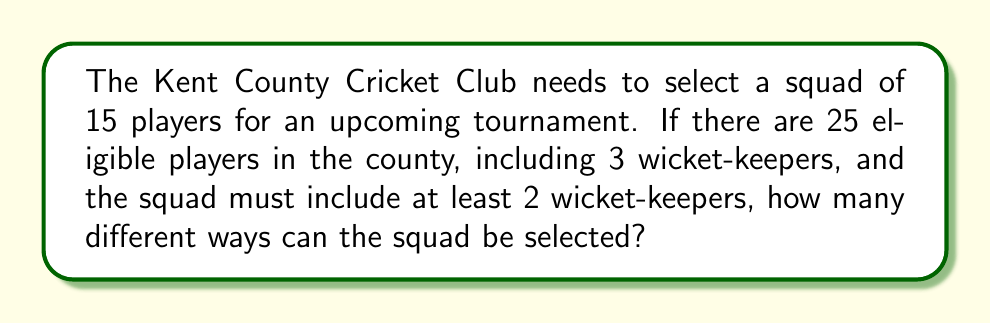What is the answer to this math problem? Let's approach this step-by-step:

1) First, we need to select the wicket-keepers:
   - We must choose at least 2 out of 3 wicket-keepers.
   - We can either choose 2 or all 3.
   - This can be done in $\binom{3}{2} + \binom{3}{3} = 3 + 1 = 4$ ways.

2) After selecting the wicket-keepers, we need to fill the remaining spots:
   - If we chose 2 wicket-keepers, we need to select 13 more players from the remaining 22.
   - If we chose 3 wicket-keepers, we need to select 12 more players from the remaining 22.

3) Let's calculate these separately:
   a) For 2 wicket-keepers: $\binom{3}{2} \times \binom{22}{13}$
   b) For 3 wicket-keepers: $\binom{3}{3} \times \binom{22}{12}$

4) Now, let's compute:
   $$\binom{3}{2} \times \binom{22}{13} + \binom{3}{3} \times \binom{22}{12}$$
   $$= 3 \times 497,420 + 1 \times 646,646$$
   $$= 1,492,260 + 646,646$$
   $$= 2,138,906$$

Therefore, the total number of ways to select the squad is 2,138,906.
Answer: 2,138,906 